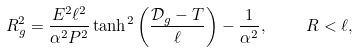Convert formula to latex. <formula><loc_0><loc_0><loc_500><loc_500>R _ { g } ^ { 2 } = \frac { E ^ { 2 } \ell ^ { 2 } } { \alpha ^ { 2 } P ^ { 2 } } \tanh ^ { 2 } \left ( \frac { \mathcal { D } _ { g } - T } { \ell } \right ) - \frac { 1 } { \alpha ^ { 2 } } , \quad \ R < \ell ,</formula> 